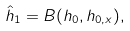Convert formula to latex. <formula><loc_0><loc_0><loc_500><loc_500>\hat { h } _ { 1 } = B ( h _ { 0 } , h _ { 0 , x } ) ,</formula> 